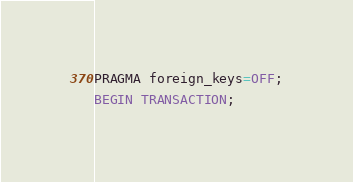Convert code to text. <code><loc_0><loc_0><loc_500><loc_500><_SQL_>PRAGMA foreign_keys=OFF;
BEGIN TRANSACTION;
</code> 